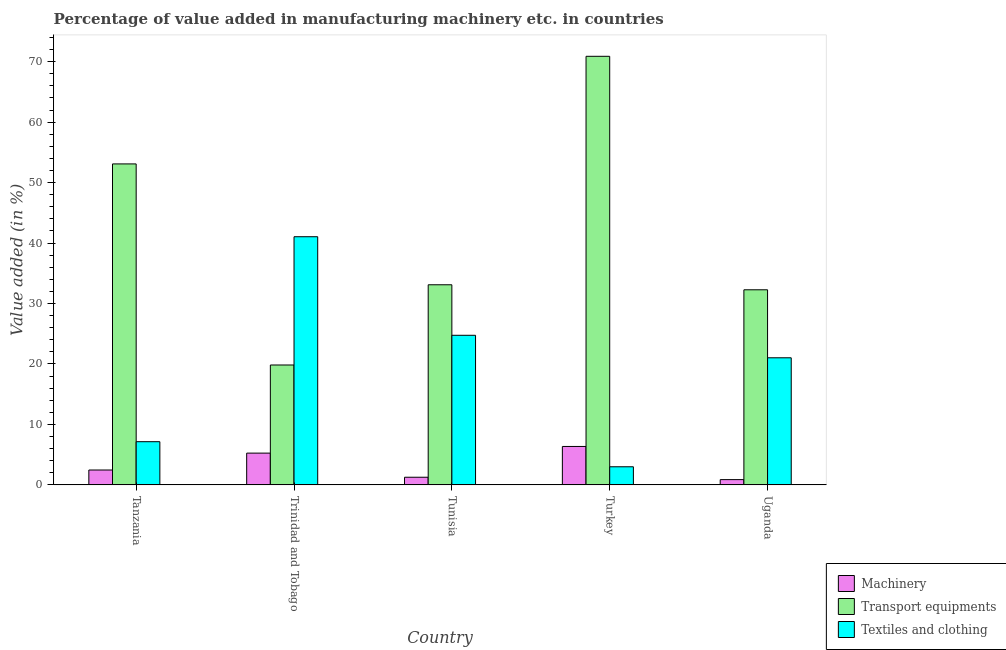How many groups of bars are there?
Keep it short and to the point. 5. Are the number of bars per tick equal to the number of legend labels?
Ensure brevity in your answer.  Yes. Are the number of bars on each tick of the X-axis equal?
Your response must be concise. Yes. How many bars are there on the 5th tick from the right?
Give a very brief answer. 3. What is the label of the 2nd group of bars from the left?
Keep it short and to the point. Trinidad and Tobago. In how many cases, is the number of bars for a given country not equal to the number of legend labels?
Your response must be concise. 0. What is the value added in manufacturing textile and clothing in Tunisia?
Give a very brief answer. 24.74. Across all countries, what is the maximum value added in manufacturing textile and clothing?
Your answer should be compact. 41.04. Across all countries, what is the minimum value added in manufacturing transport equipments?
Your answer should be very brief. 19.83. In which country was the value added in manufacturing transport equipments maximum?
Give a very brief answer. Turkey. In which country was the value added in manufacturing machinery minimum?
Your answer should be very brief. Uganda. What is the total value added in manufacturing machinery in the graph?
Provide a short and direct response. 16.21. What is the difference between the value added in manufacturing textile and clothing in Tanzania and that in Uganda?
Ensure brevity in your answer.  -13.88. What is the difference between the value added in manufacturing transport equipments in Turkey and the value added in manufacturing machinery in Trinidad and Tobago?
Provide a succinct answer. 65.63. What is the average value added in manufacturing transport equipments per country?
Make the answer very short. 41.83. What is the difference between the value added in manufacturing textile and clothing and value added in manufacturing transport equipments in Turkey?
Give a very brief answer. -67.88. What is the ratio of the value added in manufacturing textile and clothing in Tanzania to that in Tunisia?
Your answer should be compact. 0.29. Is the value added in manufacturing transport equipments in Trinidad and Tobago less than that in Turkey?
Offer a very short reply. Yes. Is the difference between the value added in manufacturing machinery in Trinidad and Tobago and Turkey greater than the difference between the value added in manufacturing transport equipments in Trinidad and Tobago and Turkey?
Provide a succinct answer. Yes. What is the difference between the highest and the second highest value added in manufacturing machinery?
Offer a very short reply. 1.1. What is the difference between the highest and the lowest value added in manufacturing transport equipments?
Ensure brevity in your answer.  51.05. What does the 2nd bar from the left in Tunisia represents?
Ensure brevity in your answer.  Transport equipments. What does the 1st bar from the right in Tanzania represents?
Your answer should be compact. Textiles and clothing. Is it the case that in every country, the sum of the value added in manufacturing machinery and value added in manufacturing transport equipments is greater than the value added in manufacturing textile and clothing?
Your answer should be very brief. No. Are all the bars in the graph horizontal?
Your response must be concise. No. How many countries are there in the graph?
Your answer should be compact. 5. What is the difference between two consecutive major ticks on the Y-axis?
Provide a short and direct response. 10. Are the values on the major ticks of Y-axis written in scientific E-notation?
Provide a short and direct response. No. Does the graph contain any zero values?
Offer a very short reply. No. Does the graph contain grids?
Provide a succinct answer. No. Where does the legend appear in the graph?
Ensure brevity in your answer.  Bottom right. How are the legend labels stacked?
Your response must be concise. Vertical. What is the title of the graph?
Offer a very short reply. Percentage of value added in manufacturing machinery etc. in countries. What is the label or title of the X-axis?
Offer a terse response. Country. What is the label or title of the Y-axis?
Keep it short and to the point. Value added (in %). What is the Value added (in %) in Machinery in Tanzania?
Provide a succinct answer. 2.46. What is the Value added (in %) in Transport equipments in Tanzania?
Make the answer very short. 53.08. What is the Value added (in %) in Textiles and clothing in Tanzania?
Provide a short and direct response. 7.14. What is the Value added (in %) in Machinery in Trinidad and Tobago?
Ensure brevity in your answer.  5.25. What is the Value added (in %) of Transport equipments in Trinidad and Tobago?
Offer a terse response. 19.83. What is the Value added (in %) of Textiles and clothing in Trinidad and Tobago?
Your response must be concise. 41.04. What is the Value added (in %) of Machinery in Tunisia?
Provide a succinct answer. 1.27. What is the Value added (in %) in Transport equipments in Tunisia?
Provide a succinct answer. 33.1. What is the Value added (in %) in Textiles and clothing in Tunisia?
Provide a short and direct response. 24.74. What is the Value added (in %) in Machinery in Turkey?
Give a very brief answer. 6.36. What is the Value added (in %) in Transport equipments in Turkey?
Ensure brevity in your answer.  70.88. What is the Value added (in %) in Textiles and clothing in Turkey?
Offer a very short reply. 3. What is the Value added (in %) in Machinery in Uganda?
Offer a terse response. 0.87. What is the Value added (in %) of Transport equipments in Uganda?
Make the answer very short. 32.27. What is the Value added (in %) in Textiles and clothing in Uganda?
Provide a succinct answer. 21.02. Across all countries, what is the maximum Value added (in %) of Machinery?
Make the answer very short. 6.36. Across all countries, what is the maximum Value added (in %) in Transport equipments?
Your answer should be very brief. 70.88. Across all countries, what is the maximum Value added (in %) of Textiles and clothing?
Your response must be concise. 41.04. Across all countries, what is the minimum Value added (in %) of Machinery?
Offer a terse response. 0.87. Across all countries, what is the minimum Value added (in %) in Transport equipments?
Provide a short and direct response. 19.83. Across all countries, what is the minimum Value added (in %) of Textiles and clothing?
Keep it short and to the point. 3. What is the total Value added (in %) in Machinery in the graph?
Ensure brevity in your answer.  16.21. What is the total Value added (in %) of Transport equipments in the graph?
Your answer should be very brief. 209.16. What is the total Value added (in %) of Textiles and clothing in the graph?
Provide a succinct answer. 96.95. What is the difference between the Value added (in %) in Machinery in Tanzania and that in Trinidad and Tobago?
Your answer should be compact. -2.79. What is the difference between the Value added (in %) of Transport equipments in Tanzania and that in Trinidad and Tobago?
Make the answer very short. 33.25. What is the difference between the Value added (in %) of Textiles and clothing in Tanzania and that in Trinidad and Tobago?
Your answer should be compact. -33.9. What is the difference between the Value added (in %) of Machinery in Tanzania and that in Tunisia?
Keep it short and to the point. 1.19. What is the difference between the Value added (in %) in Transport equipments in Tanzania and that in Tunisia?
Make the answer very short. 19.99. What is the difference between the Value added (in %) in Textiles and clothing in Tanzania and that in Tunisia?
Provide a succinct answer. -17.6. What is the difference between the Value added (in %) of Machinery in Tanzania and that in Turkey?
Ensure brevity in your answer.  -3.9. What is the difference between the Value added (in %) in Transport equipments in Tanzania and that in Turkey?
Provide a succinct answer. -17.8. What is the difference between the Value added (in %) in Textiles and clothing in Tanzania and that in Turkey?
Offer a very short reply. 4.15. What is the difference between the Value added (in %) in Machinery in Tanzania and that in Uganda?
Your answer should be very brief. 1.59. What is the difference between the Value added (in %) of Transport equipments in Tanzania and that in Uganda?
Give a very brief answer. 20.82. What is the difference between the Value added (in %) in Textiles and clothing in Tanzania and that in Uganda?
Your answer should be very brief. -13.88. What is the difference between the Value added (in %) of Machinery in Trinidad and Tobago and that in Tunisia?
Your answer should be compact. 3.99. What is the difference between the Value added (in %) in Transport equipments in Trinidad and Tobago and that in Tunisia?
Make the answer very short. -13.27. What is the difference between the Value added (in %) of Textiles and clothing in Trinidad and Tobago and that in Tunisia?
Offer a terse response. 16.3. What is the difference between the Value added (in %) of Machinery in Trinidad and Tobago and that in Turkey?
Offer a terse response. -1.1. What is the difference between the Value added (in %) in Transport equipments in Trinidad and Tobago and that in Turkey?
Your answer should be very brief. -51.05. What is the difference between the Value added (in %) in Textiles and clothing in Trinidad and Tobago and that in Turkey?
Your response must be concise. 38.05. What is the difference between the Value added (in %) in Machinery in Trinidad and Tobago and that in Uganda?
Make the answer very short. 4.38. What is the difference between the Value added (in %) in Transport equipments in Trinidad and Tobago and that in Uganda?
Your response must be concise. -12.44. What is the difference between the Value added (in %) of Textiles and clothing in Trinidad and Tobago and that in Uganda?
Your response must be concise. 20.02. What is the difference between the Value added (in %) in Machinery in Tunisia and that in Turkey?
Offer a terse response. -5.09. What is the difference between the Value added (in %) of Transport equipments in Tunisia and that in Turkey?
Provide a succinct answer. -37.78. What is the difference between the Value added (in %) in Textiles and clothing in Tunisia and that in Turkey?
Offer a very short reply. 21.75. What is the difference between the Value added (in %) of Machinery in Tunisia and that in Uganda?
Your answer should be compact. 0.39. What is the difference between the Value added (in %) in Transport equipments in Tunisia and that in Uganda?
Provide a short and direct response. 0.83. What is the difference between the Value added (in %) in Textiles and clothing in Tunisia and that in Uganda?
Make the answer very short. 3.72. What is the difference between the Value added (in %) in Machinery in Turkey and that in Uganda?
Give a very brief answer. 5.48. What is the difference between the Value added (in %) in Transport equipments in Turkey and that in Uganda?
Your response must be concise. 38.61. What is the difference between the Value added (in %) of Textiles and clothing in Turkey and that in Uganda?
Make the answer very short. -18.02. What is the difference between the Value added (in %) in Machinery in Tanzania and the Value added (in %) in Transport equipments in Trinidad and Tobago?
Your response must be concise. -17.37. What is the difference between the Value added (in %) in Machinery in Tanzania and the Value added (in %) in Textiles and clothing in Trinidad and Tobago?
Keep it short and to the point. -38.58. What is the difference between the Value added (in %) of Transport equipments in Tanzania and the Value added (in %) of Textiles and clothing in Trinidad and Tobago?
Provide a short and direct response. 12.04. What is the difference between the Value added (in %) of Machinery in Tanzania and the Value added (in %) of Transport equipments in Tunisia?
Your answer should be very brief. -30.64. What is the difference between the Value added (in %) of Machinery in Tanzania and the Value added (in %) of Textiles and clothing in Tunisia?
Make the answer very short. -22.28. What is the difference between the Value added (in %) in Transport equipments in Tanzania and the Value added (in %) in Textiles and clothing in Tunisia?
Provide a succinct answer. 28.34. What is the difference between the Value added (in %) in Machinery in Tanzania and the Value added (in %) in Transport equipments in Turkey?
Your answer should be compact. -68.42. What is the difference between the Value added (in %) of Machinery in Tanzania and the Value added (in %) of Textiles and clothing in Turkey?
Make the answer very short. -0.54. What is the difference between the Value added (in %) of Transport equipments in Tanzania and the Value added (in %) of Textiles and clothing in Turkey?
Your answer should be very brief. 50.09. What is the difference between the Value added (in %) of Machinery in Tanzania and the Value added (in %) of Transport equipments in Uganda?
Your answer should be compact. -29.81. What is the difference between the Value added (in %) of Machinery in Tanzania and the Value added (in %) of Textiles and clothing in Uganda?
Your response must be concise. -18.56. What is the difference between the Value added (in %) in Transport equipments in Tanzania and the Value added (in %) in Textiles and clothing in Uganda?
Provide a short and direct response. 32.06. What is the difference between the Value added (in %) of Machinery in Trinidad and Tobago and the Value added (in %) of Transport equipments in Tunisia?
Make the answer very short. -27.84. What is the difference between the Value added (in %) of Machinery in Trinidad and Tobago and the Value added (in %) of Textiles and clothing in Tunisia?
Give a very brief answer. -19.49. What is the difference between the Value added (in %) in Transport equipments in Trinidad and Tobago and the Value added (in %) in Textiles and clothing in Tunisia?
Your answer should be compact. -4.91. What is the difference between the Value added (in %) of Machinery in Trinidad and Tobago and the Value added (in %) of Transport equipments in Turkey?
Give a very brief answer. -65.63. What is the difference between the Value added (in %) in Machinery in Trinidad and Tobago and the Value added (in %) in Textiles and clothing in Turkey?
Keep it short and to the point. 2.26. What is the difference between the Value added (in %) of Transport equipments in Trinidad and Tobago and the Value added (in %) of Textiles and clothing in Turkey?
Offer a terse response. 16.83. What is the difference between the Value added (in %) in Machinery in Trinidad and Tobago and the Value added (in %) in Transport equipments in Uganda?
Give a very brief answer. -27.01. What is the difference between the Value added (in %) of Machinery in Trinidad and Tobago and the Value added (in %) of Textiles and clothing in Uganda?
Your response must be concise. -15.77. What is the difference between the Value added (in %) of Transport equipments in Trinidad and Tobago and the Value added (in %) of Textiles and clothing in Uganda?
Your answer should be compact. -1.19. What is the difference between the Value added (in %) of Machinery in Tunisia and the Value added (in %) of Transport equipments in Turkey?
Offer a terse response. -69.61. What is the difference between the Value added (in %) of Machinery in Tunisia and the Value added (in %) of Textiles and clothing in Turkey?
Give a very brief answer. -1.73. What is the difference between the Value added (in %) in Transport equipments in Tunisia and the Value added (in %) in Textiles and clothing in Turkey?
Provide a succinct answer. 30.1. What is the difference between the Value added (in %) of Machinery in Tunisia and the Value added (in %) of Transport equipments in Uganda?
Your response must be concise. -31. What is the difference between the Value added (in %) in Machinery in Tunisia and the Value added (in %) in Textiles and clothing in Uganda?
Keep it short and to the point. -19.75. What is the difference between the Value added (in %) in Transport equipments in Tunisia and the Value added (in %) in Textiles and clothing in Uganda?
Your answer should be very brief. 12.07. What is the difference between the Value added (in %) in Machinery in Turkey and the Value added (in %) in Transport equipments in Uganda?
Provide a short and direct response. -25.91. What is the difference between the Value added (in %) of Machinery in Turkey and the Value added (in %) of Textiles and clothing in Uganda?
Make the answer very short. -14.66. What is the difference between the Value added (in %) of Transport equipments in Turkey and the Value added (in %) of Textiles and clothing in Uganda?
Keep it short and to the point. 49.86. What is the average Value added (in %) in Machinery per country?
Offer a very short reply. 3.24. What is the average Value added (in %) of Transport equipments per country?
Provide a short and direct response. 41.83. What is the average Value added (in %) in Textiles and clothing per country?
Your answer should be compact. 19.39. What is the difference between the Value added (in %) of Machinery and Value added (in %) of Transport equipments in Tanzania?
Provide a short and direct response. -50.62. What is the difference between the Value added (in %) of Machinery and Value added (in %) of Textiles and clothing in Tanzania?
Keep it short and to the point. -4.68. What is the difference between the Value added (in %) of Transport equipments and Value added (in %) of Textiles and clothing in Tanzania?
Your response must be concise. 45.94. What is the difference between the Value added (in %) of Machinery and Value added (in %) of Transport equipments in Trinidad and Tobago?
Ensure brevity in your answer.  -14.58. What is the difference between the Value added (in %) of Machinery and Value added (in %) of Textiles and clothing in Trinidad and Tobago?
Offer a terse response. -35.79. What is the difference between the Value added (in %) in Transport equipments and Value added (in %) in Textiles and clothing in Trinidad and Tobago?
Provide a short and direct response. -21.21. What is the difference between the Value added (in %) of Machinery and Value added (in %) of Transport equipments in Tunisia?
Provide a short and direct response. -31.83. What is the difference between the Value added (in %) of Machinery and Value added (in %) of Textiles and clothing in Tunisia?
Offer a terse response. -23.48. What is the difference between the Value added (in %) of Transport equipments and Value added (in %) of Textiles and clothing in Tunisia?
Give a very brief answer. 8.35. What is the difference between the Value added (in %) in Machinery and Value added (in %) in Transport equipments in Turkey?
Keep it short and to the point. -64.52. What is the difference between the Value added (in %) of Machinery and Value added (in %) of Textiles and clothing in Turkey?
Your answer should be compact. 3.36. What is the difference between the Value added (in %) of Transport equipments and Value added (in %) of Textiles and clothing in Turkey?
Your response must be concise. 67.88. What is the difference between the Value added (in %) in Machinery and Value added (in %) in Transport equipments in Uganda?
Give a very brief answer. -31.39. What is the difference between the Value added (in %) of Machinery and Value added (in %) of Textiles and clothing in Uganda?
Ensure brevity in your answer.  -20.15. What is the difference between the Value added (in %) of Transport equipments and Value added (in %) of Textiles and clothing in Uganda?
Provide a short and direct response. 11.25. What is the ratio of the Value added (in %) of Machinery in Tanzania to that in Trinidad and Tobago?
Give a very brief answer. 0.47. What is the ratio of the Value added (in %) of Transport equipments in Tanzania to that in Trinidad and Tobago?
Provide a short and direct response. 2.68. What is the ratio of the Value added (in %) of Textiles and clothing in Tanzania to that in Trinidad and Tobago?
Ensure brevity in your answer.  0.17. What is the ratio of the Value added (in %) in Machinery in Tanzania to that in Tunisia?
Ensure brevity in your answer.  1.94. What is the ratio of the Value added (in %) in Transport equipments in Tanzania to that in Tunisia?
Keep it short and to the point. 1.6. What is the ratio of the Value added (in %) in Textiles and clothing in Tanzania to that in Tunisia?
Offer a very short reply. 0.29. What is the ratio of the Value added (in %) of Machinery in Tanzania to that in Turkey?
Give a very brief answer. 0.39. What is the ratio of the Value added (in %) in Transport equipments in Tanzania to that in Turkey?
Offer a very short reply. 0.75. What is the ratio of the Value added (in %) in Textiles and clothing in Tanzania to that in Turkey?
Give a very brief answer. 2.38. What is the ratio of the Value added (in %) of Machinery in Tanzania to that in Uganda?
Provide a succinct answer. 2.82. What is the ratio of the Value added (in %) in Transport equipments in Tanzania to that in Uganda?
Give a very brief answer. 1.65. What is the ratio of the Value added (in %) in Textiles and clothing in Tanzania to that in Uganda?
Make the answer very short. 0.34. What is the ratio of the Value added (in %) in Machinery in Trinidad and Tobago to that in Tunisia?
Provide a short and direct response. 4.15. What is the ratio of the Value added (in %) of Transport equipments in Trinidad and Tobago to that in Tunisia?
Keep it short and to the point. 0.6. What is the ratio of the Value added (in %) of Textiles and clothing in Trinidad and Tobago to that in Tunisia?
Ensure brevity in your answer.  1.66. What is the ratio of the Value added (in %) of Machinery in Trinidad and Tobago to that in Turkey?
Your answer should be compact. 0.83. What is the ratio of the Value added (in %) of Transport equipments in Trinidad and Tobago to that in Turkey?
Offer a terse response. 0.28. What is the ratio of the Value added (in %) of Textiles and clothing in Trinidad and Tobago to that in Turkey?
Provide a succinct answer. 13.69. What is the ratio of the Value added (in %) of Machinery in Trinidad and Tobago to that in Uganda?
Provide a short and direct response. 6.02. What is the ratio of the Value added (in %) of Transport equipments in Trinidad and Tobago to that in Uganda?
Give a very brief answer. 0.61. What is the ratio of the Value added (in %) of Textiles and clothing in Trinidad and Tobago to that in Uganda?
Offer a very short reply. 1.95. What is the ratio of the Value added (in %) in Machinery in Tunisia to that in Turkey?
Keep it short and to the point. 0.2. What is the ratio of the Value added (in %) in Transport equipments in Tunisia to that in Turkey?
Give a very brief answer. 0.47. What is the ratio of the Value added (in %) of Textiles and clothing in Tunisia to that in Turkey?
Offer a very short reply. 8.26. What is the ratio of the Value added (in %) in Machinery in Tunisia to that in Uganda?
Make the answer very short. 1.45. What is the ratio of the Value added (in %) of Transport equipments in Tunisia to that in Uganda?
Your answer should be very brief. 1.03. What is the ratio of the Value added (in %) of Textiles and clothing in Tunisia to that in Uganda?
Provide a succinct answer. 1.18. What is the ratio of the Value added (in %) in Machinery in Turkey to that in Uganda?
Your answer should be very brief. 7.28. What is the ratio of the Value added (in %) in Transport equipments in Turkey to that in Uganda?
Offer a terse response. 2.2. What is the ratio of the Value added (in %) in Textiles and clothing in Turkey to that in Uganda?
Provide a succinct answer. 0.14. What is the difference between the highest and the second highest Value added (in %) in Machinery?
Ensure brevity in your answer.  1.1. What is the difference between the highest and the second highest Value added (in %) in Transport equipments?
Make the answer very short. 17.8. What is the difference between the highest and the second highest Value added (in %) of Textiles and clothing?
Provide a short and direct response. 16.3. What is the difference between the highest and the lowest Value added (in %) in Machinery?
Your answer should be very brief. 5.48. What is the difference between the highest and the lowest Value added (in %) of Transport equipments?
Keep it short and to the point. 51.05. What is the difference between the highest and the lowest Value added (in %) in Textiles and clothing?
Ensure brevity in your answer.  38.05. 